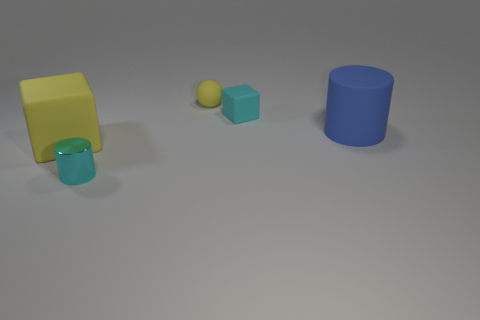What is the color of the large matte thing left of the yellow object that is on the right side of the cyan shiny cylinder?
Keep it short and to the point. Yellow. What is the color of the rubber ball that is the same size as the cyan metallic object?
Ensure brevity in your answer.  Yellow. What number of small objects are either cyan cylinders or yellow matte things?
Your answer should be compact. 2. Are there more yellow things that are to the right of the tiny yellow object than cyan rubber blocks that are to the left of the tiny metallic cylinder?
Your answer should be very brief. No. What is the size of the matte object that is the same color as the small shiny object?
Make the answer very short. Small. What number of other objects are the same size as the cyan metallic cylinder?
Your answer should be very brief. 2. Are the small cyan object that is behind the large yellow matte object and the big yellow thing made of the same material?
Your answer should be very brief. Yes. What number of other objects are the same color as the small shiny thing?
Offer a very short reply. 1. How many other things are the same shape as the blue thing?
Make the answer very short. 1. Do the small cyan object left of the tiny matte ball and the large object that is to the right of the cyan metal cylinder have the same shape?
Your response must be concise. Yes. 